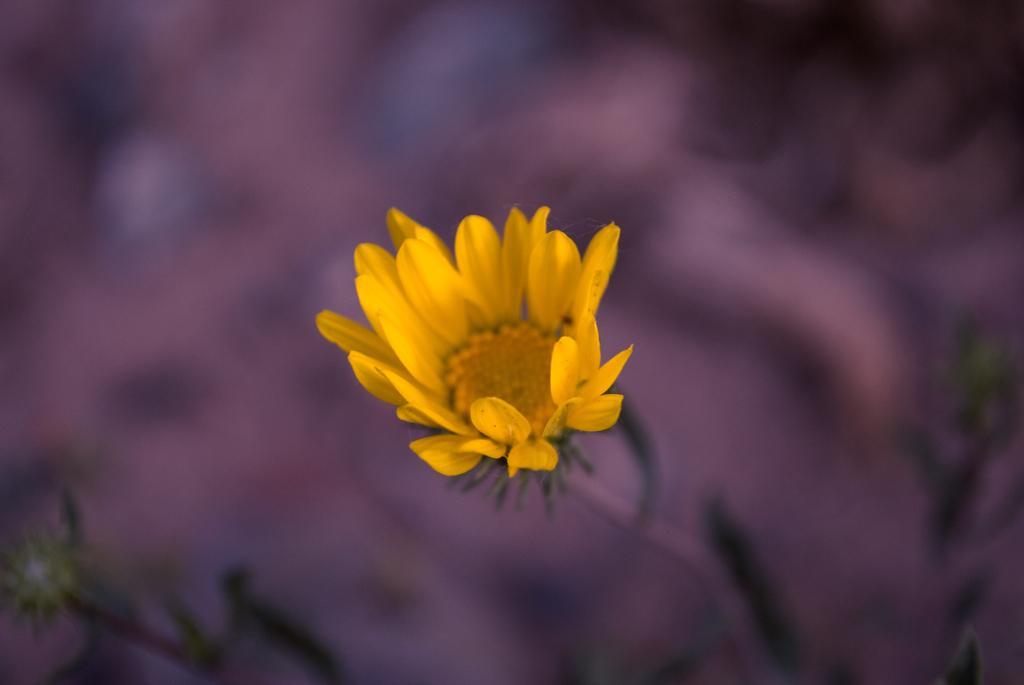Please provide a concise description of this image. In this picture we can see a flower to the stem. Behind the flower there is the blurred background. 